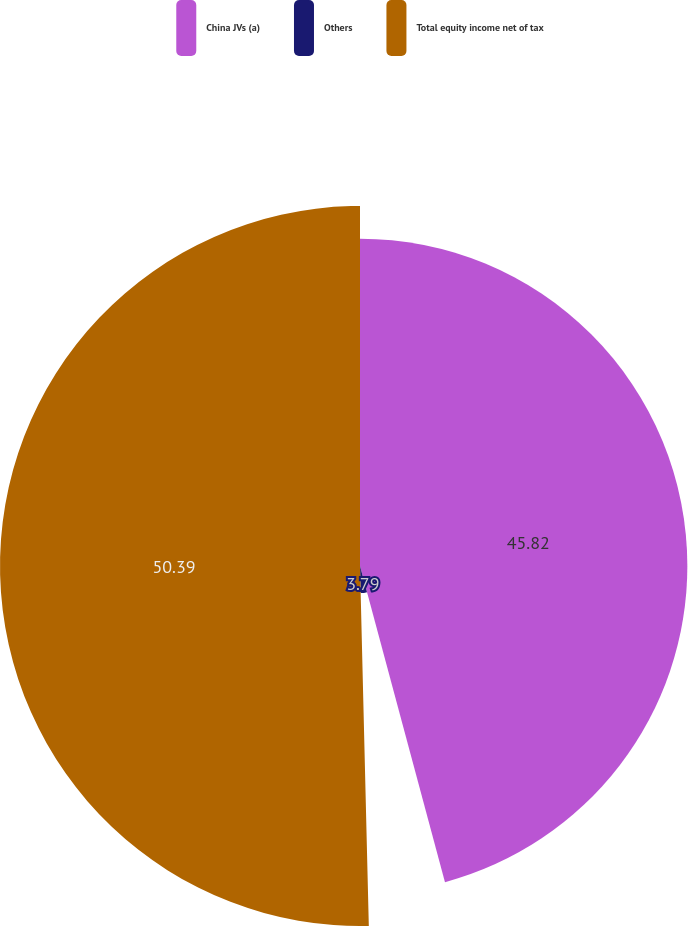Convert chart to OTSL. <chart><loc_0><loc_0><loc_500><loc_500><pie_chart><fcel>China JVs (a)<fcel>Others<fcel>Total equity income net of tax<nl><fcel>45.82%<fcel>3.79%<fcel>50.39%<nl></chart> 